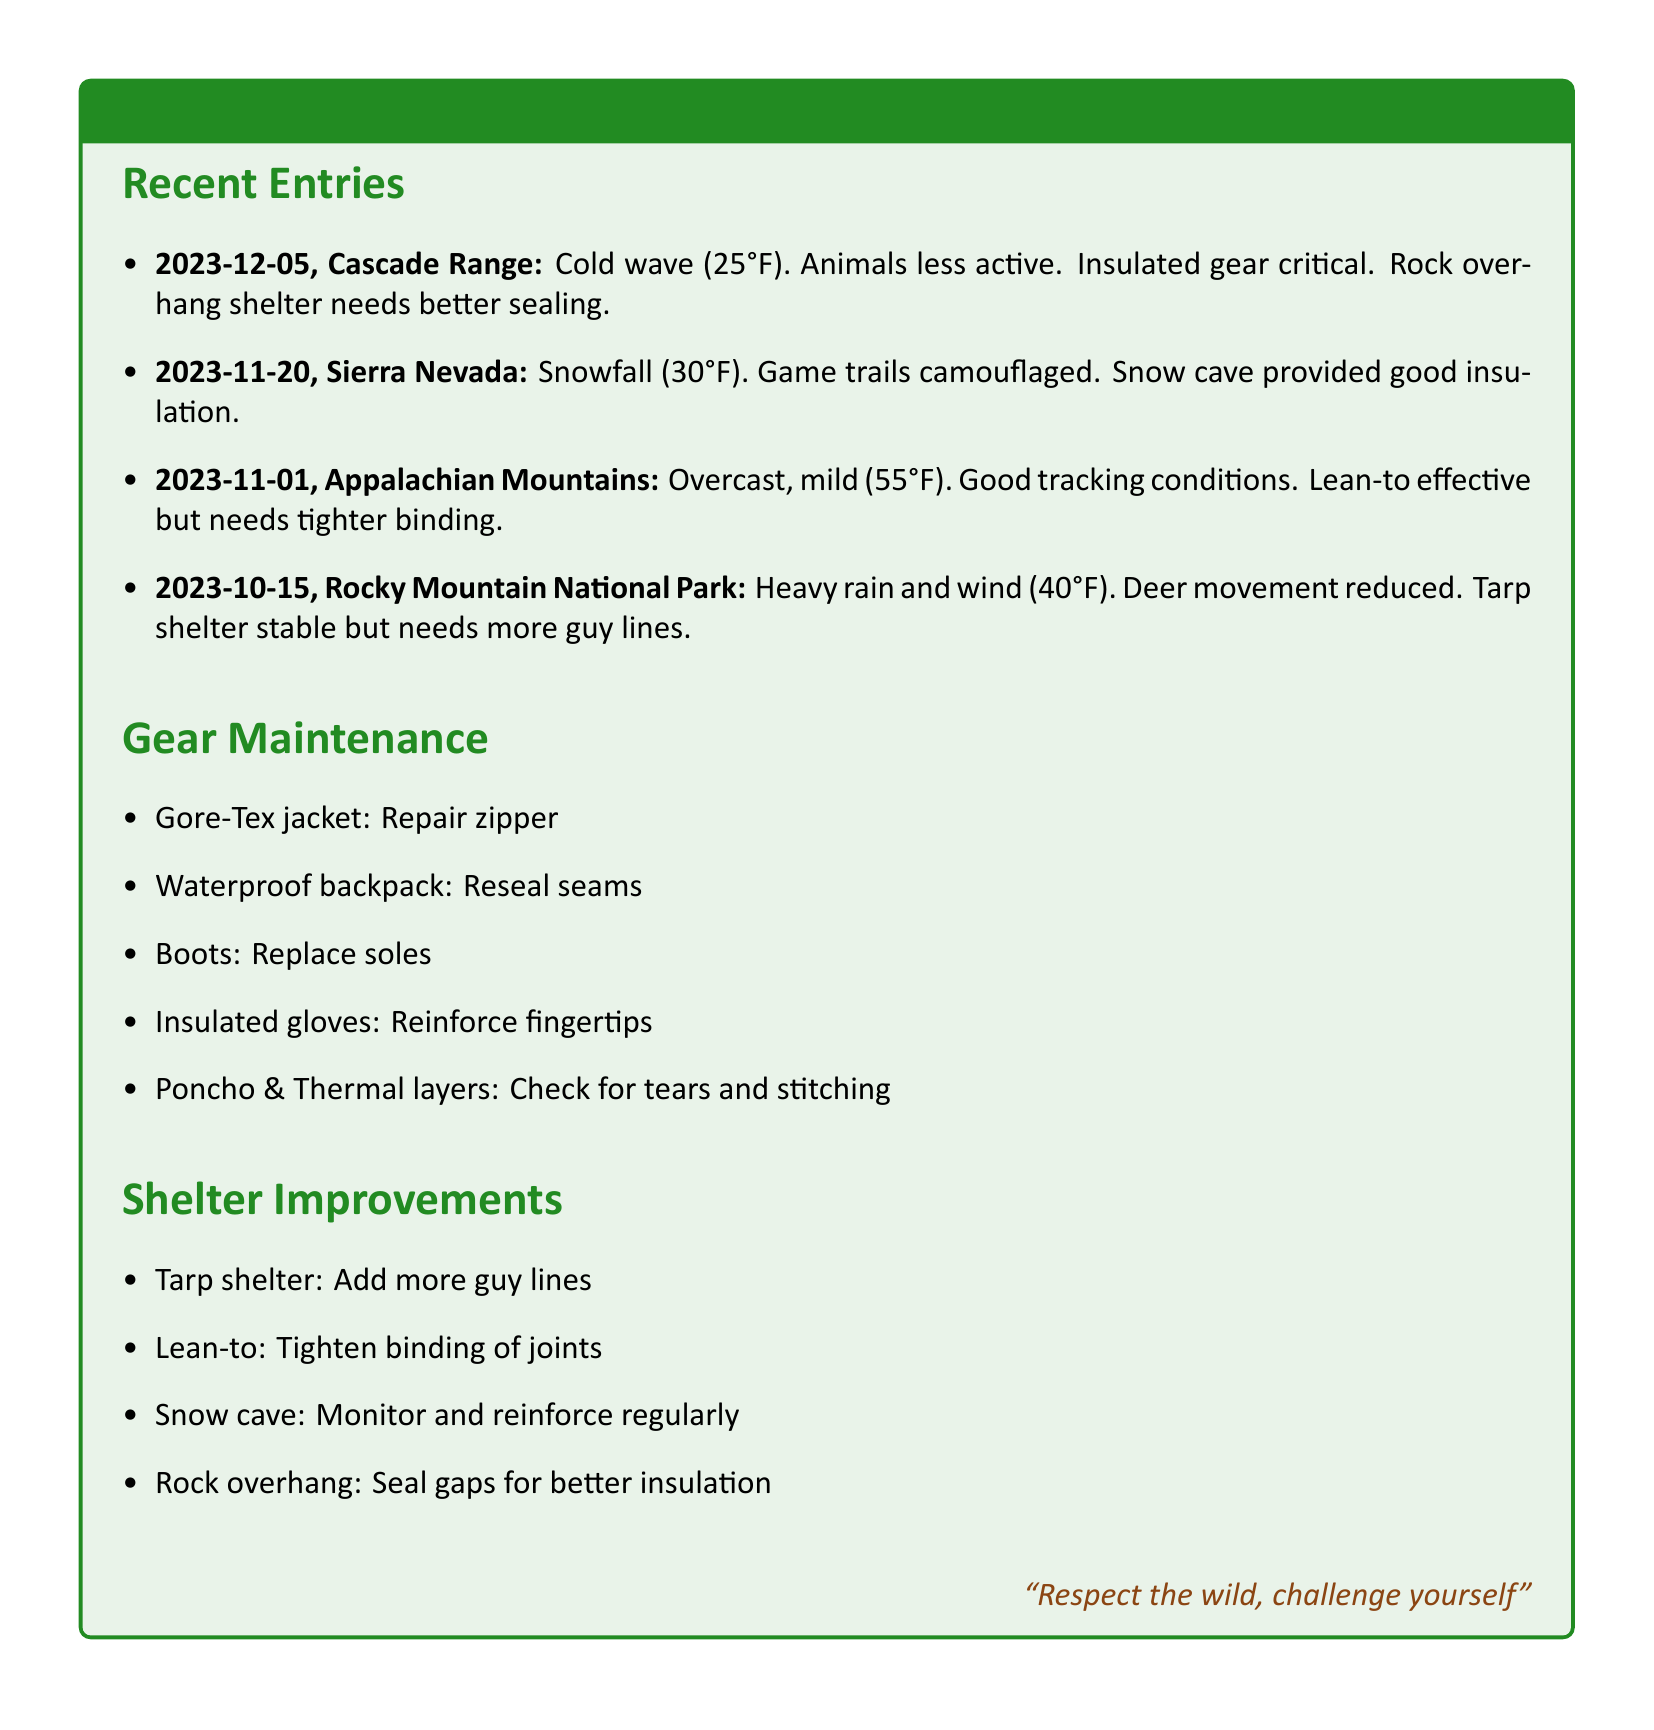what was the date of the cold wave in Cascade Range? The date of the cold wave in Cascade Range is the first entry listed in the Recent Entries section, which is 2023-12-05.
Answer: 2023-12-05 what was the temperature during the snowfall in Sierra Nevada? The temperature during the snowfall in Sierra Nevada, as noted in the entry, was 30°F.
Answer: 30°F which type of shelter provided good insulation during the snowfall? The shelter that provided good insulation during the snowfall in Sierra Nevada is a snow cave, as mentioned in the log.
Answer: snow cave what maintenance is needed for the Gore-Tex jacket? The maintenance needed for the Gore-Tex jacket, as stated in the Gear Maintenance section, is to repair the zipper.
Answer: Repair zipper how should the tarp shelter be improved? The tarp shelter should be improved by adding more guy lines, as noted in the Shelter Improvements section.
Answer: Add more guy lines what was the weather condition on November 1st in the Appalachian Mountains? The weather condition on November 1st in the Appalachian Mountains was overcast and mild, as described in the entry.
Answer: overcast, mild what type of gloves need reinforcement? The type of gloves that need reinforcement are insulated gloves, as mentioned in the Gear Maintenance section.
Answer: insulated gloves which shelter experienced heavy rain and wind on October 15th? The shelter that experienced heavy rain and wind on October 15th is the tarp shelter, as noted in the log.
Answer: tarp shelter what specific action is noted for the rock overhang in the Shelter Improvements? The specific action noted for the rock overhang is to seal gaps for better insulation, as mentioned in the Shelter Improvements section.
Answer: Seal gaps for better insulation 